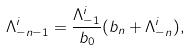Convert formula to latex. <formula><loc_0><loc_0><loc_500><loc_500>\Lambda ^ { i } _ { - n - 1 } = \frac { \Lambda ^ { i } _ { - 1 } } { b _ { 0 } } ( b _ { n } + \Lambda ^ { i } _ { - n } ) ,</formula> 